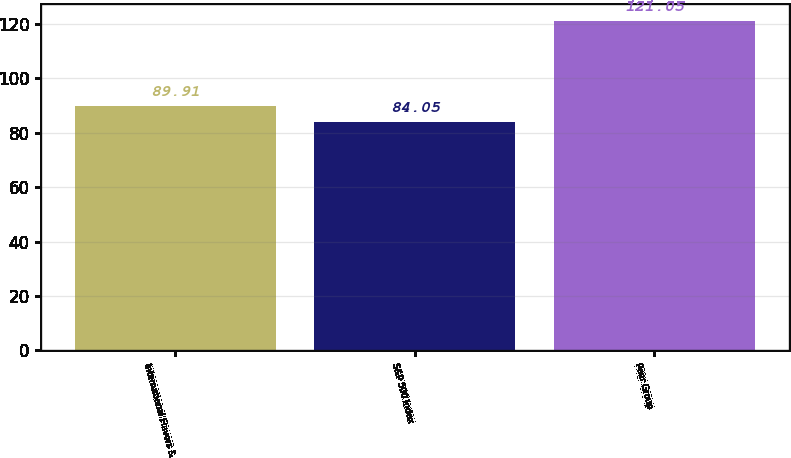Convert chart. <chart><loc_0><loc_0><loc_500><loc_500><bar_chart><fcel>International Flavors &<fcel>S&P 500 Index<fcel>Peer Group<nl><fcel>89.91<fcel>84.05<fcel>121.05<nl></chart> 